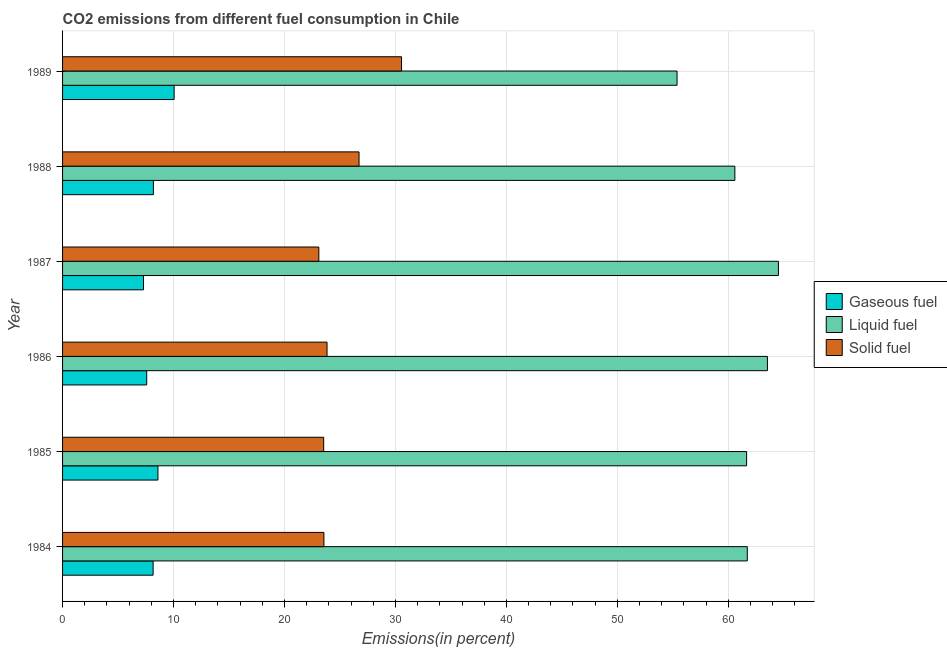How many different coloured bars are there?
Make the answer very short. 3. How many groups of bars are there?
Provide a short and direct response. 6. Are the number of bars per tick equal to the number of legend labels?
Your response must be concise. Yes. Are the number of bars on each tick of the Y-axis equal?
Ensure brevity in your answer.  Yes. How many bars are there on the 1st tick from the top?
Give a very brief answer. 3. What is the label of the 3rd group of bars from the top?
Your response must be concise. 1987. What is the percentage of gaseous fuel emission in 1986?
Make the answer very short. 7.58. Across all years, what is the maximum percentage of gaseous fuel emission?
Keep it short and to the point. 10.05. Across all years, what is the minimum percentage of gaseous fuel emission?
Keep it short and to the point. 7.29. In which year was the percentage of gaseous fuel emission maximum?
Provide a succinct answer. 1989. In which year was the percentage of liquid fuel emission minimum?
Your answer should be very brief. 1989. What is the total percentage of liquid fuel emission in the graph?
Your response must be concise. 367.36. What is the difference between the percentage of solid fuel emission in 1984 and that in 1987?
Keep it short and to the point. 0.46. What is the difference between the percentage of gaseous fuel emission in 1984 and the percentage of solid fuel emission in 1989?
Provide a short and direct response. -22.39. What is the average percentage of liquid fuel emission per year?
Your answer should be very brief. 61.23. In the year 1987, what is the difference between the percentage of solid fuel emission and percentage of liquid fuel emission?
Make the answer very short. -41.42. What is the ratio of the percentage of gaseous fuel emission in 1985 to that in 1987?
Your answer should be very brief. 1.18. Is the percentage of liquid fuel emission in 1984 less than that in 1986?
Provide a succinct answer. Yes. What is the difference between the highest and the lowest percentage of liquid fuel emission?
Your answer should be very brief. 9.14. What does the 3rd bar from the top in 1987 represents?
Your answer should be compact. Gaseous fuel. What does the 3rd bar from the bottom in 1985 represents?
Give a very brief answer. Solid fuel. How many bars are there?
Offer a terse response. 18. Are all the bars in the graph horizontal?
Provide a succinct answer. Yes. How many years are there in the graph?
Offer a very short reply. 6. What is the difference between two consecutive major ticks on the X-axis?
Give a very brief answer. 10. Are the values on the major ticks of X-axis written in scientific E-notation?
Make the answer very short. No. Does the graph contain grids?
Ensure brevity in your answer.  Yes. What is the title of the graph?
Ensure brevity in your answer.  CO2 emissions from different fuel consumption in Chile. What is the label or title of the X-axis?
Your response must be concise. Emissions(in percent). What is the Emissions(in percent) in Gaseous fuel in 1984?
Offer a terse response. 8.16. What is the Emissions(in percent) in Liquid fuel in 1984?
Offer a terse response. 61.71. What is the Emissions(in percent) in Solid fuel in 1984?
Make the answer very short. 23.55. What is the Emissions(in percent) in Gaseous fuel in 1985?
Offer a terse response. 8.59. What is the Emissions(in percent) in Liquid fuel in 1985?
Offer a terse response. 61.65. What is the Emissions(in percent) in Solid fuel in 1985?
Your answer should be very brief. 23.53. What is the Emissions(in percent) of Gaseous fuel in 1986?
Make the answer very short. 7.58. What is the Emissions(in percent) of Liquid fuel in 1986?
Make the answer very short. 63.52. What is the Emissions(in percent) in Solid fuel in 1986?
Make the answer very short. 23.83. What is the Emissions(in percent) of Gaseous fuel in 1987?
Your answer should be compact. 7.29. What is the Emissions(in percent) in Liquid fuel in 1987?
Provide a short and direct response. 64.52. What is the Emissions(in percent) in Solid fuel in 1987?
Give a very brief answer. 23.1. What is the Emissions(in percent) of Gaseous fuel in 1988?
Keep it short and to the point. 8.18. What is the Emissions(in percent) of Liquid fuel in 1988?
Provide a succinct answer. 60.59. What is the Emissions(in percent) of Solid fuel in 1988?
Give a very brief answer. 26.72. What is the Emissions(in percent) in Gaseous fuel in 1989?
Your answer should be very brief. 10.05. What is the Emissions(in percent) in Liquid fuel in 1989?
Your answer should be very brief. 55.38. What is the Emissions(in percent) of Solid fuel in 1989?
Your response must be concise. 30.55. Across all years, what is the maximum Emissions(in percent) of Gaseous fuel?
Keep it short and to the point. 10.05. Across all years, what is the maximum Emissions(in percent) in Liquid fuel?
Provide a short and direct response. 64.52. Across all years, what is the maximum Emissions(in percent) in Solid fuel?
Your answer should be compact. 30.55. Across all years, what is the minimum Emissions(in percent) of Gaseous fuel?
Offer a very short reply. 7.29. Across all years, what is the minimum Emissions(in percent) of Liquid fuel?
Your answer should be compact. 55.38. Across all years, what is the minimum Emissions(in percent) in Solid fuel?
Make the answer very short. 23.1. What is the total Emissions(in percent) in Gaseous fuel in the graph?
Your response must be concise. 49.87. What is the total Emissions(in percent) in Liquid fuel in the graph?
Give a very brief answer. 367.36. What is the total Emissions(in percent) in Solid fuel in the graph?
Offer a terse response. 151.28. What is the difference between the Emissions(in percent) of Gaseous fuel in 1984 and that in 1985?
Your answer should be compact. -0.43. What is the difference between the Emissions(in percent) of Liquid fuel in 1984 and that in 1985?
Offer a very short reply. 0.06. What is the difference between the Emissions(in percent) of Solid fuel in 1984 and that in 1985?
Your response must be concise. 0.02. What is the difference between the Emissions(in percent) of Gaseous fuel in 1984 and that in 1986?
Provide a short and direct response. 0.58. What is the difference between the Emissions(in percent) of Liquid fuel in 1984 and that in 1986?
Offer a terse response. -1.81. What is the difference between the Emissions(in percent) in Solid fuel in 1984 and that in 1986?
Make the answer very short. -0.28. What is the difference between the Emissions(in percent) of Gaseous fuel in 1984 and that in 1987?
Offer a terse response. 0.87. What is the difference between the Emissions(in percent) in Liquid fuel in 1984 and that in 1987?
Your response must be concise. -2.8. What is the difference between the Emissions(in percent) of Solid fuel in 1984 and that in 1987?
Offer a terse response. 0.46. What is the difference between the Emissions(in percent) of Gaseous fuel in 1984 and that in 1988?
Ensure brevity in your answer.  -0.02. What is the difference between the Emissions(in percent) of Liquid fuel in 1984 and that in 1988?
Provide a succinct answer. 1.12. What is the difference between the Emissions(in percent) in Solid fuel in 1984 and that in 1988?
Keep it short and to the point. -3.16. What is the difference between the Emissions(in percent) in Gaseous fuel in 1984 and that in 1989?
Your answer should be very brief. -1.89. What is the difference between the Emissions(in percent) of Liquid fuel in 1984 and that in 1989?
Your answer should be compact. 6.33. What is the difference between the Emissions(in percent) of Solid fuel in 1984 and that in 1989?
Your answer should be compact. -6.99. What is the difference between the Emissions(in percent) of Gaseous fuel in 1985 and that in 1986?
Offer a very short reply. 1.01. What is the difference between the Emissions(in percent) of Liquid fuel in 1985 and that in 1986?
Give a very brief answer. -1.88. What is the difference between the Emissions(in percent) in Solid fuel in 1985 and that in 1986?
Your answer should be compact. -0.3. What is the difference between the Emissions(in percent) of Gaseous fuel in 1985 and that in 1987?
Your answer should be compact. 1.3. What is the difference between the Emissions(in percent) of Liquid fuel in 1985 and that in 1987?
Provide a succinct answer. -2.87. What is the difference between the Emissions(in percent) of Solid fuel in 1985 and that in 1987?
Your answer should be very brief. 0.44. What is the difference between the Emissions(in percent) of Gaseous fuel in 1985 and that in 1988?
Keep it short and to the point. 0.41. What is the difference between the Emissions(in percent) in Liquid fuel in 1985 and that in 1988?
Offer a terse response. 1.06. What is the difference between the Emissions(in percent) of Solid fuel in 1985 and that in 1988?
Offer a very short reply. -3.19. What is the difference between the Emissions(in percent) in Gaseous fuel in 1985 and that in 1989?
Keep it short and to the point. -1.46. What is the difference between the Emissions(in percent) in Liquid fuel in 1985 and that in 1989?
Provide a short and direct response. 6.27. What is the difference between the Emissions(in percent) of Solid fuel in 1985 and that in 1989?
Provide a succinct answer. -7.01. What is the difference between the Emissions(in percent) of Gaseous fuel in 1986 and that in 1987?
Offer a terse response. 0.29. What is the difference between the Emissions(in percent) in Liquid fuel in 1986 and that in 1987?
Make the answer very short. -0.99. What is the difference between the Emissions(in percent) in Solid fuel in 1986 and that in 1987?
Your answer should be compact. 0.74. What is the difference between the Emissions(in percent) of Gaseous fuel in 1986 and that in 1988?
Your answer should be compact. -0.6. What is the difference between the Emissions(in percent) of Liquid fuel in 1986 and that in 1988?
Make the answer very short. 2.94. What is the difference between the Emissions(in percent) of Solid fuel in 1986 and that in 1988?
Ensure brevity in your answer.  -2.89. What is the difference between the Emissions(in percent) in Gaseous fuel in 1986 and that in 1989?
Offer a very short reply. -2.47. What is the difference between the Emissions(in percent) in Liquid fuel in 1986 and that in 1989?
Your answer should be very brief. 8.15. What is the difference between the Emissions(in percent) of Solid fuel in 1986 and that in 1989?
Offer a terse response. -6.71. What is the difference between the Emissions(in percent) in Gaseous fuel in 1987 and that in 1988?
Your answer should be compact. -0.89. What is the difference between the Emissions(in percent) in Liquid fuel in 1987 and that in 1988?
Provide a succinct answer. 3.93. What is the difference between the Emissions(in percent) in Solid fuel in 1987 and that in 1988?
Your answer should be compact. -3.62. What is the difference between the Emissions(in percent) of Gaseous fuel in 1987 and that in 1989?
Your response must be concise. -2.76. What is the difference between the Emissions(in percent) of Liquid fuel in 1987 and that in 1989?
Your answer should be compact. 9.14. What is the difference between the Emissions(in percent) in Solid fuel in 1987 and that in 1989?
Make the answer very short. -7.45. What is the difference between the Emissions(in percent) of Gaseous fuel in 1988 and that in 1989?
Offer a terse response. -1.87. What is the difference between the Emissions(in percent) of Liquid fuel in 1988 and that in 1989?
Provide a short and direct response. 5.21. What is the difference between the Emissions(in percent) in Solid fuel in 1988 and that in 1989?
Ensure brevity in your answer.  -3.83. What is the difference between the Emissions(in percent) in Gaseous fuel in 1984 and the Emissions(in percent) in Liquid fuel in 1985?
Offer a very short reply. -53.49. What is the difference between the Emissions(in percent) in Gaseous fuel in 1984 and the Emissions(in percent) in Solid fuel in 1985?
Keep it short and to the point. -15.37. What is the difference between the Emissions(in percent) in Liquid fuel in 1984 and the Emissions(in percent) in Solid fuel in 1985?
Keep it short and to the point. 38.18. What is the difference between the Emissions(in percent) in Gaseous fuel in 1984 and the Emissions(in percent) in Liquid fuel in 1986?
Ensure brevity in your answer.  -55.36. What is the difference between the Emissions(in percent) of Gaseous fuel in 1984 and the Emissions(in percent) of Solid fuel in 1986?
Keep it short and to the point. -15.67. What is the difference between the Emissions(in percent) in Liquid fuel in 1984 and the Emissions(in percent) in Solid fuel in 1986?
Your answer should be very brief. 37.88. What is the difference between the Emissions(in percent) of Gaseous fuel in 1984 and the Emissions(in percent) of Liquid fuel in 1987?
Offer a very short reply. -56.36. What is the difference between the Emissions(in percent) of Gaseous fuel in 1984 and the Emissions(in percent) of Solid fuel in 1987?
Offer a very short reply. -14.94. What is the difference between the Emissions(in percent) in Liquid fuel in 1984 and the Emissions(in percent) in Solid fuel in 1987?
Give a very brief answer. 38.62. What is the difference between the Emissions(in percent) in Gaseous fuel in 1984 and the Emissions(in percent) in Liquid fuel in 1988?
Make the answer very short. -52.43. What is the difference between the Emissions(in percent) in Gaseous fuel in 1984 and the Emissions(in percent) in Solid fuel in 1988?
Provide a succinct answer. -18.56. What is the difference between the Emissions(in percent) in Liquid fuel in 1984 and the Emissions(in percent) in Solid fuel in 1988?
Your response must be concise. 34.99. What is the difference between the Emissions(in percent) in Gaseous fuel in 1984 and the Emissions(in percent) in Liquid fuel in 1989?
Offer a very short reply. -47.22. What is the difference between the Emissions(in percent) in Gaseous fuel in 1984 and the Emissions(in percent) in Solid fuel in 1989?
Offer a very short reply. -22.39. What is the difference between the Emissions(in percent) in Liquid fuel in 1984 and the Emissions(in percent) in Solid fuel in 1989?
Offer a terse response. 31.16. What is the difference between the Emissions(in percent) of Gaseous fuel in 1985 and the Emissions(in percent) of Liquid fuel in 1986?
Your answer should be very brief. -54.93. What is the difference between the Emissions(in percent) in Gaseous fuel in 1985 and the Emissions(in percent) in Solid fuel in 1986?
Offer a terse response. -15.24. What is the difference between the Emissions(in percent) in Liquid fuel in 1985 and the Emissions(in percent) in Solid fuel in 1986?
Your answer should be very brief. 37.81. What is the difference between the Emissions(in percent) of Gaseous fuel in 1985 and the Emissions(in percent) of Liquid fuel in 1987?
Your response must be concise. -55.92. What is the difference between the Emissions(in percent) of Gaseous fuel in 1985 and the Emissions(in percent) of Solid fuel in 1987?
Provide a short and direct response. -14.5. What is the difference between the Emissions(in percent) of Liquid fuel in 1985 and the Emissions(in percent) of Solid fuel in 1987?
Make the answer very short. 38.55. What is the difference between the Emissions(in percent) of Gaseous fuel in 1985 and the Emissions(in percent) of Liquid fuel in 1988?
Your answer should be very brief. -51.99. What is the difference between the Emissions(in percent) of Gaseous fuel in 1985 and the Emissions(in percent) of Solid fuel in 1988?
Your answer should be compact. -18.12. What is the difference between the Emissions(in percent) in Liquid fuel in 1985 and the Emissions(in percent) in Solid fuel in 1988?
Your response must be concise. 34.93. What is the difference between the Emissions(in percent) in Gaseous fuel in 1985 and the Emissions(in percent) in Liquid fuel in 1989?
Your response must be concise. -46.78. What is the difference between the Emissions(in percent) in Gaseous fuel in 1985 and the Emissions(in percent) in Solid fuel in 1989?
Make the answer very short. -21.95. What is the difference between the Emissions(in percent) of Liquid fuel in 1985 and the Emissions(in percent) of Solid fuel in 1989?
Keep it short and to the point. 31.1. What is the difference between the Emissions(in percent) of Gaseous fuel in 1986 and the Emissions(in percent) of Liquid fuel in 1987?
Offer a very short reply. -56.93. What is the difference between the Emissions(in percent) in Gaseous fuel in 1986 and the Emissions(in percent) in Solid fuel in 1987?
Your answer should be compact. -15.51. What is the difference between the Emissions(in percent) in Liquid fuel in 1986 and the Emissions(in percent) in Solid fuel in 1987?
Offer a very short reply. 40.43. What is the difference between the Emissions(in percent) of Gaseous fuel in 1986 and the Emissions(in percent) of Liquid fuel in 1988?
Offer a very short reply. -53.01. What is the difference between the Emissions(in percent) of Gaseous fuel in 1986 and the Emissions(in percent) of Solid fuel in 1988?
Give a very brief answer. -19.14. What is the difference between the Emissions(in percent) of Liquid fuel in 1986 and the Emissions(in percent) of Solid fuel in 1988?
Make the answer very short. 36.8. What is the difference between the Emissions(in percent) of Gaseous fuel in 1986 and the Emissions(in percent) of Liquid fuel in 1989?
Offer a very short reply. -47.8. What is the difference between the Emissions(in percent) of Gaseous fuel in 1986 and the Emissions(in percent) of Solid fuel in 1989?
Your answer should be very brief. -22.97. What is the difference between the Emissions(in percent) in Liquid fuel in 1986 and the Emissions(in percent) in Solid fuel in 1989?
Ensure brevity in your answer.  32.98. What is the difference between the Emissions(in percent) of Gaseous fuel in 1987 and the Emissions(in percent) of Liquid fuel in 1988?
Your answer should be compact. -53.29. What is the difference between the Emissions(in percent) in Gaseous fuel in 1987 and the Emissions(in percent) in Solid fuel in 1988?
Make the answer very short. -19.43. What is the difference between the Emissions(in percent) of Liquid fuel in 1987 and the Emissions(in percent) of Solid fuel in 1988?
Offer a very short reply. 37.8. What is the difference between the Emissions(in percent) of Gaseous fuel in 1987 and the Emissions(in percent) of Liquid fuel in 1989?
Your answer should be compact. -48.08. What is the difference between the Emissions(in percent) of Gaseous fuel in 1987 and the Emissions(in percent) of Solid fuel in 1989?
Offer a very short reply. -23.25. What is the difference between the Emissions(in percent) of Liquid fuel in 1987 and the Emissions(in percent) of Solid fuel in 1989?
Keep it short and to the point. 33.97. What is the difference between the Emissions(in percent) in Gaseous fuel in 1988 and the Emissions(in percent) in Liquid fuel in 1989?
Keep it short and to the point. -47.19. What is the difference between the Emissions(in percent) of Gaseous fuel in 1988 and the Emissions(in percent) of Solid fuel in 1989?
Ensure brevity in your answer.  -22.36. What is the difference between the Emissions(in percent) in Liquid fuel in 1988 and the Emissions(in percent) in Solid fuel in 1989?
Your response must be concise. 30.04. What is the average Emissions(in percent) of Gaseous fuel per year?
Keep it short and to the point. 8.31. What is the average Emissions(in percent) in Liquid fuel per year?
Keep it short and to the point. 61.23. What is the average Emissions(in percent) of Solid fuel per year?
Provide a succinct answer. 25.21. In the year 1984, what is the difference between the Emissions(in percent) in Gaseous fuel and Emissions(in percent) in Liquid fuel?
Offer a very short reply. -53.55. In the year 1984, what is the difference between the Emissions(in percent) of Gaseous fuel and Emissions(in percent) of Solid fuel?
Keep it short and to the point. -15.39. In the year 1984, what is the difference between the Emissions(in percent) in Liquid fuel and Emissions(in percent) in Solid fuel?
Your response must be concise. 38.16. In the year 1985, what is the difference between the Emissions(in percent) of Gaseous fuel and Emissions(in percent) of Liquid fuel?
Keep it short and to the point. -53.05. In the year 1985, what is the difference between the Emissions(in percent) of Gaseous fuel and Emissions(in percent) of Solid fuel?
Your answer should be very brief. -14.94. In the year 1985, what is the difference between the Emissions(in percent) of Liquid fuel and Emissions(in percent) of Solid fuel?
Your response must be concise. 38.11. In the year 1986, what is the difference between the Emissions(in percent) of Gaseous fuel and Emissions(in percent) of Liquid fuel?
Ensure brevity in your answer.  -55.94. In the year 1986, what is the difference between the Emissions(in percent) in Gaseous fuel and Emissions(in percent) in Solid fuel?
Ensure brevity in your answer.  -16.25. In the year 1986, what is the difference between the Emissions(in percent) of Liquid fuel and Emissions(in percent) of Solid fuel?
Provide a succinct answer. 39.69. In the year 1987, what is the difference between the Emissions(in percent) in Gaseous fuel and Emissions(in percent) in Liquid fuel?
Keep it short and to the point. -57.22. In the year 1987, what is the difference between the Emissions(in percent) in Gaseous fuel and Emissions(in percent) in Solid fuel?
Your response must be concise. -15.8. In the year 1987, what is the difference between the Emissions(in percent) of Liquid fuel and Emissions(in percent) of Solid fuel?
Offer a terse response. 41.42. In the year 1988, what is the difference between the Emissions(in percent) of Gaseous fuel and Emissions(in percent) of Liquid fuel?
Your answer should be compact. -52.4. In the year 1988, what is the difference between the Emissions(in percent) in Gaseous fuel and Emissions(in percent) in Solid fuel?
Provide a short and direct response. -18.53. In the year 1988, what is the difference between the Emissions(in percent) in Liquid fuel and Emissions(in percent) in Solid fuel?
Your answer should be compact. 33.87. In the year 1989, what is the difference between the Emissions(in percent) of Gaseous fuel and Emissions(in percent) of Liquid fuel?
Ensure brevity in your answer.  -45.32. In the year 1989, what is the difference between the Emissions(in percent) in Gaseous fuel and Emissions(in percent) in Solid fuel?
Provide a succinct answer. -20.49. In the year 1989, what is the difference between the Emissions(in percent) in Liquid fuel and Emissions(in percent) in Solid fuel?
Keep it short and to the point. 24.83. What is the ratio of the Emissions(in percent) in Gaseous fuel in 1984 to that in 1985?
Make the answer very short. 0.95. What is the ratio of the Emissions(in percent) in Liquid fuel in 1984 to that in 1985?
Offer a very short reply. 1. What is the ratio of the Emissions(in percent) in Solid fuel in 1984 to that in 1985?
Your answer should be very brief. 1. What is the ratio of the Emissions(in percent) of Gaseous fuel in 1984 to that in 1986?
Your answer should be compact. 1.08. What is the ratio of the Emissions(in percent) in Liquid fuel in 1984 to that in 1986?
Provide a succinct answer. 0.97. What is the ratio of the Emissions(in percent) of Solid fuel in 1984 to that in 1986?
Keep it short and to the point. 0.99. What is the ratio of the Emissions(in percent) of Gaseous fuel in 1984 to that in 1987?
Provide a short and direct response. 1.12. What is the ratio of the Emissions(in percent) of Liquid fuel in 1984 to that in 1987?
Give a very brief answer. 0.96. What is the ratio of the Emissions(in percent) of Solid fuel in 1984 to that in 1987?
Your answer should be compact. 1.02. What is the ratio of the Emissions(in percent) in Gaseous fuel in 1984 to that in 1988?
Provide a short and direct response. 1. What is the ratio of the Emissions(in percent) in Liquid fuel in 1984 to that in 1988?
Your answer should be compact. 1.02. What is the ratio of the Emissions(in percent) of Solid fuel in 1984 to that in 1988?
Your response must be concise. 0.88. What is the ratio of the Emissions(in percent) in Gaseous fuel in 1984 to that in 1989?
Your answer should be very brief. 0.81. What is the ratio of the Emissions(in percent) of Liquid fuel in 1984 to that in 1989?
Your response must be concise. 1.11. What is the ratio of the Emissions(in percent) of Solid fuel in 1984 to that in 1989?
Your answer should be compact. 0.77. What is the ratio of the Emissions(in percent) of Gaseous fuel in 1985 to that in 1986?
Give a very brief answer. 1.13. What is the ratio of the Emissions(in percent) in Liquid fuel in 1985 to that in 1986?
Give a very brief answer. 0.97. What is the ratio of the Emissions(in percent) in Solid fuel in 1985 to that in 1986?
Provide a succinct answer. 0.99. What is the ratio of the Emissions(in percent) in Gaseous fuel in 1985 to that in 1987?
Offer a terse response. 1.18. What is the ratio of the Emissions(in percent) of Liquid fuel in 1985 to that in 1987?
Make the answer very short. 0.96. What is the ratio of the Emissions(in percent) of Solid fuel in 1985 to that in 1987?
Make the answer very short. 1.02. What is the ratio of the Emissions(in percent) in Gaseous fuel in 1985 to that in 1988?
Offer a terse response. 1.05. What is the ratio of the Emissions(in percent) of Liquid fuel in 1985 to that in 1988?
Give a very brief answer. 1.02. What is the ratio of the Emissions(in percent) of Solid fuel in 1985 to that in 1988?
Your answer should be very brief. 0.88. What is the ratio of the Emissions(in percent) of Gaseous fuel in 1985 to that in 1989?
Your answer should be compact. 0.85. What is the ratio of the Emissions(in percent) in Liquid fuel in 1985 to that in 1989?
Make the answer very short. 1.11. What is the ratio of the Emissions(in percent) in Solid fuel in 1985 to that in 1989?
Offer a terse response. 0.77. What is the ratio of the Emissions(in percent) of Gaseous fuel in 1986 to that in 1987?
Your response must be concise. 1.04. What is the ratio of the Emissions(in percent) in Liquid fuel in 1986 to that in 1987?
Offer a very short reply. 0.98. What is the ratio of the Emissions(in percent) in Solid fuel in 1986 to that in 1987?
Your response must be concise. 1.03. What is the ratio of the Emissions(in percent) in Gaseous fuel in 1986 to that in 1988?
Ensure brevity in your answer.  0.93. What is the ratio of the Emissions(in percent) in Liquid fuel in 1986 to that in 1988?
Your answer should be very brief. 1.05. What is the ratio of the Emissions(in percent) of Solid fuel in 1986 to that in 1988?
Your response must be concise. 0.89. What is the ratio of the Emissions(in percent) in Gaseous fuel in 1986 to that in 1989?
Offer a terse response. 0.75. What is the ratio of the Emissions(in percent) of Liquid fuel in 1986 to that in 1989?
Provide a short and direct response. 1.15. What is the ratio of the Emissions(in percent) of Solid fuel in 1986 to that in 1989?
Your answer should be very brief. 0.78. What is the ratio of the Emissions(in percent) of Gaseous fuel in 1987 to that in 1988?
Ensure brevity in your answer.  0.89. What is the ratio of the Emissions(in percent) in Liquid fuel in 1987 to that in 1988?
Give a very brief answer. 1.06. What is the ratio of the Emissions(in percent) of Solid fuel in 1987 to that in 1988?
Provide a succinct answer. 0.86. What is the ratio of the Emissions(in percent) in Gaseous fuel in 1987 to that in 1989?
Provide a short and direct response. 0.73. What is the ratio of the Emissions(in percent) in Liquid fuel in 1987 to that in 1989?
Give a very brief answer. 1.17. What is the ratio of the Emissions(in percent) in Solid fuel in 1987 to that in 1989?
Your answer should be compact. 0.76. What is the ratio of the Emissions(in percent) of Gaseous fuel in 1988 to that in 1989?
Keep it short and to the point. 0.81. What is the ratio of the Emissions(in percent) of Liquid fuel in 1988 to that in 1989?
Offer a terse response. 1.09. What is the ratio of the Emissions(in percent) of Solid fuel in 1988 to that in 1989?
Provide a short and direct response. 0.87. What is the difference between the highest and the second highest Emissions(in percent) of Gaseous fuel?
Provide a succinct answer. 1.46. What is the difference between the highest and the second highest Emissions(in percent) in Solid fuel?
Ensure brevity in your answer.  3.83. What is the difference between the highest and the lowest Emissions(in percent) of Gaseous fuel?
Your answer should be compact. 2.76. What is the difference between the highest and the lowest Emissions(in percent) of Liquid fuel?
Provide a succinct answer. 9.14. What is the difference between the highest and the lowest Emissions(in percent) of Solid fuel?
Keep it short and to the point. 7.45. 